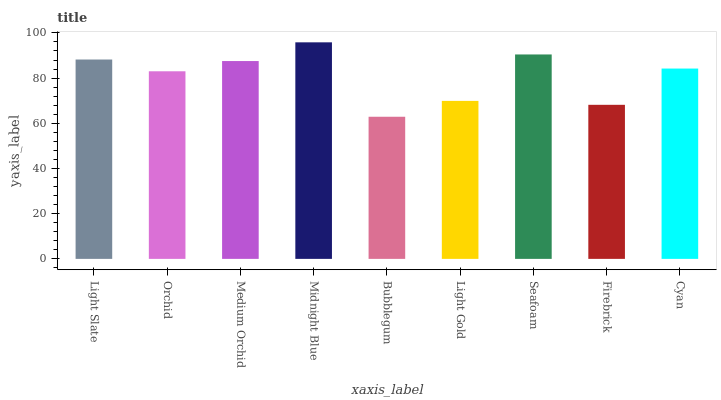Is Bubblegum the minimum?
Answer yes or no. Yes. Is Midnight Blue the maximum?
Answer yes or no. Yes. Is Orchid the minimum?
Answer yes or no. No. Is Orchid the maximum?
Answer yes or no. No. Is Light Slate greater than Orchid?
Answer yes or no. Yes. Is Orchid less than Light Slate?
Answer yes or no. Yes. Is Orchid greater than Light Slate?
Answer yes or no. No. Is Light Slate less than Orchid?
Answer yes or no. No. Is Cyan the high median?
Answer yes or no. Yes. Is Cyan the low median?
Answer yes or no. Yes. Is Firebrick the high median?
Answer yes or no. No. Is Light Slate the low median?
Answer yes or no. No. 